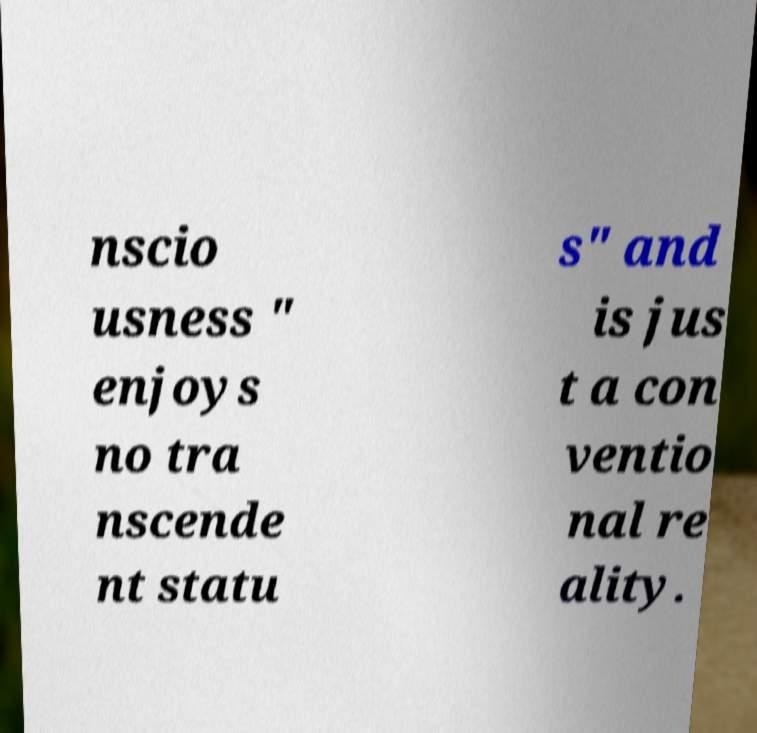Could you extract and type out the text from this image? nscio usness " enjoys no tra nscende nt statu s" and is jus t a con ventio nal re ality. 